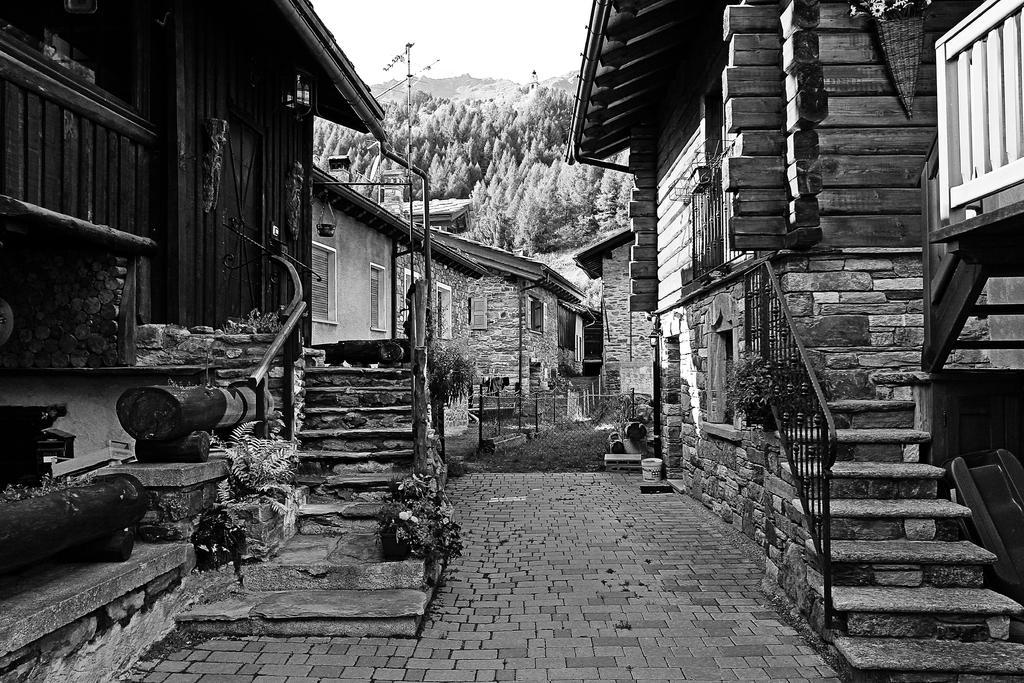Please provide a concise description of this image. In this image I can see few buildings, windows, flowerpots, stairs, trees, net fencing and the image is in black and white. 